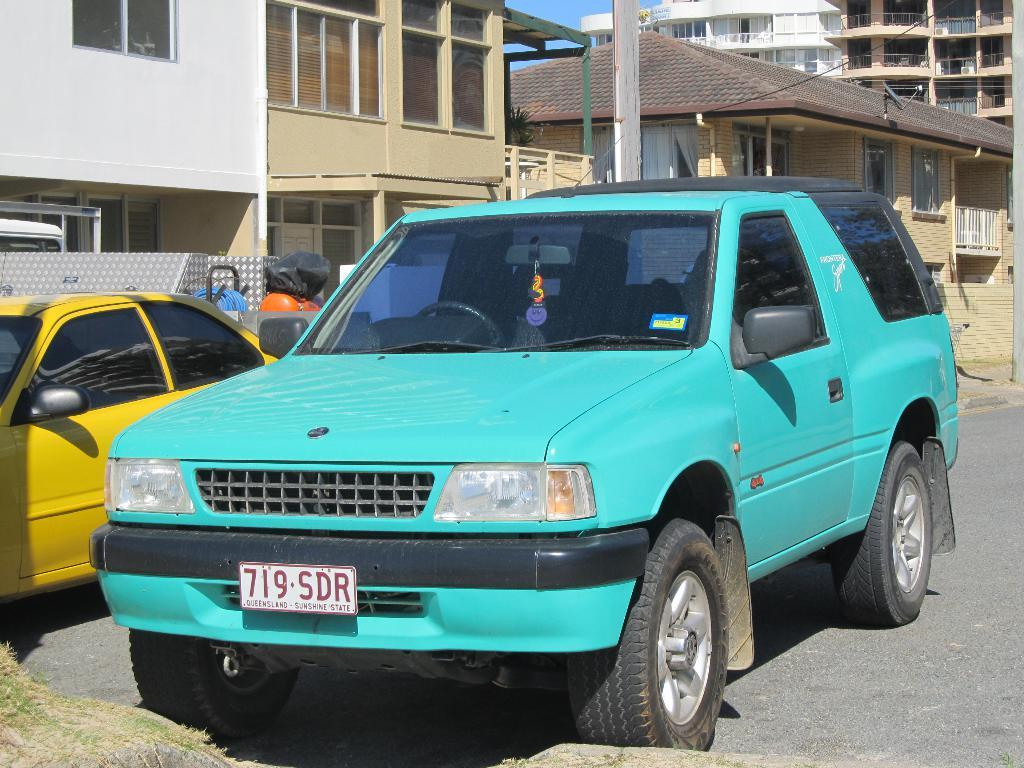<image>
Give a short and clear explanation of the subsequent image. The Sunshine state SUV with tag number 719-SDR is turquoise in color. 